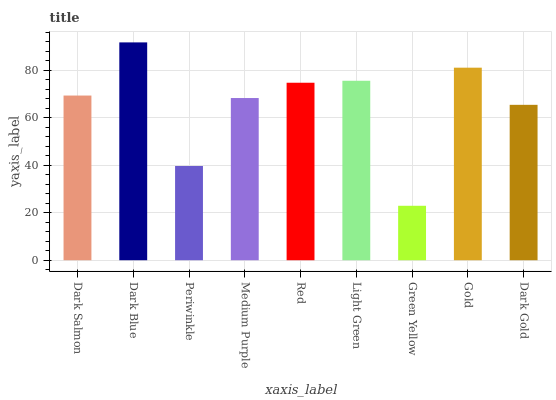Is Green Yellow the minimum?
Answer yes or no. Yes. Is Dark Blue the maximum?
Answer yes or no. Yes. Is Periwinkle the minimum?
Answer yes or no. No. Is Periwinkle the maximum?
Answer yes or no. No. Is Dark Blue greater than Periwinkle?
Answer yes or no. Yes. Is Periwinkle less than Dark Blue?
Answer yes or no. Yes. Is Periwinkle greater than Dark Blue?
Answer yes or no. No. Is Dark Blue less than Periwinkle?
Answer yes or no. No. Is Dark Salmon the high median?
Answer yes or no. Yes. Is Dark Salmon the low median?
Answer yes or no. Yes. Is Dark Blue the high median?
Answer yes or no. No. Is Red the low median?
Answer yes or no. No. 